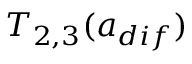<formula> <loc_0><loc_0><loc_500><loc_500>T _ { 2 , 3 } ( a _ { d i f } )</formula> 